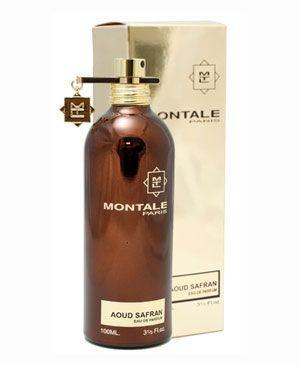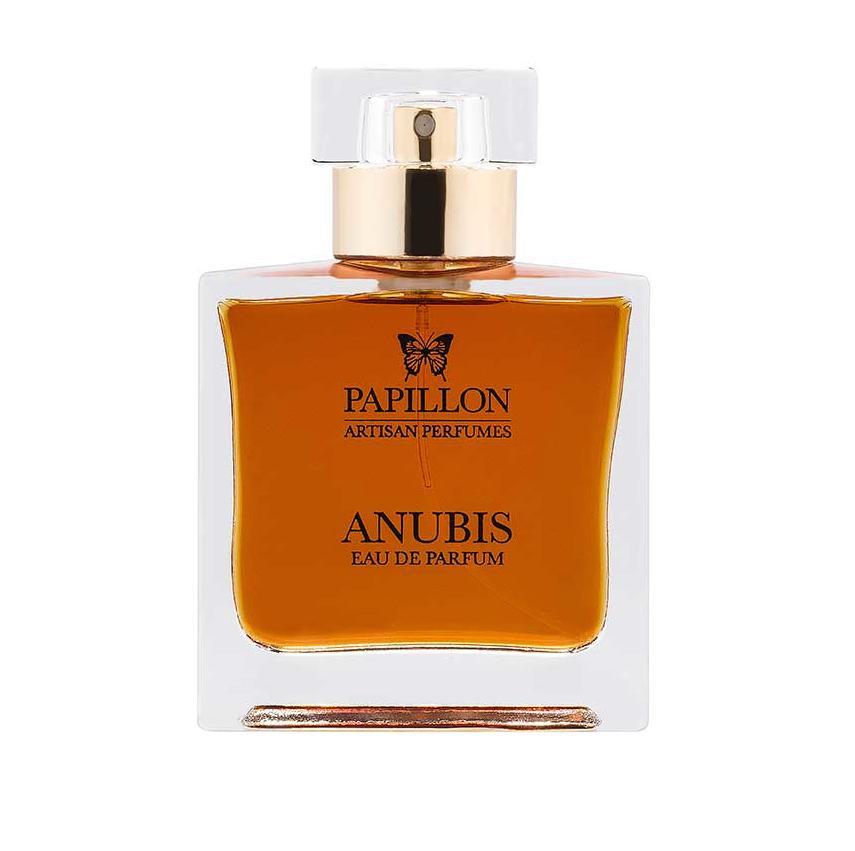The first image is the image on the left, the second image is the image on the right. For the images shown, is this caption "One image shows a fragrance bottle of brown liquid with a black label and a glass-look cap shaped somewhat like a T." true? Answer yes or no. No. 